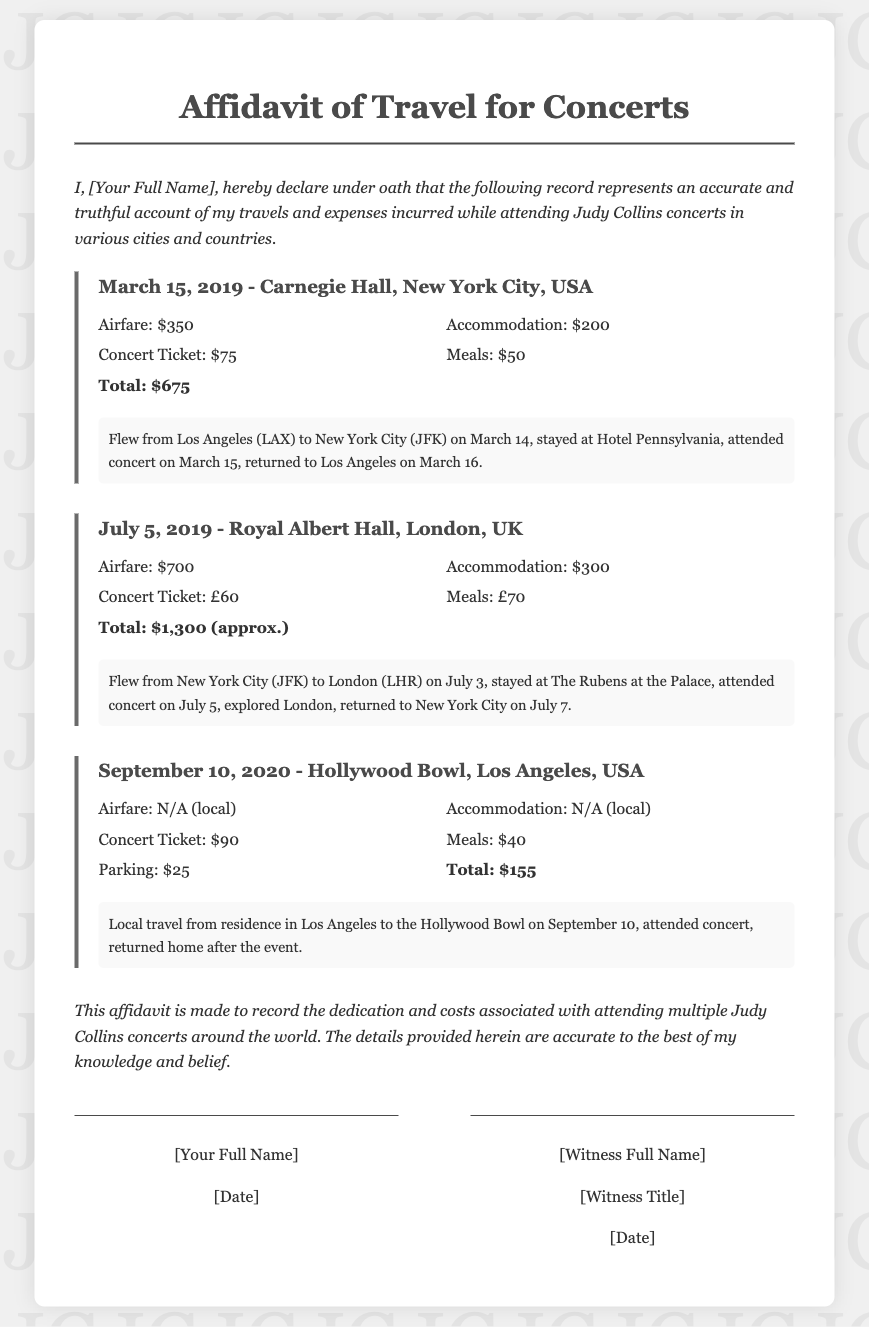What is the date of the concert at Carnegie Hall? The concert at Carnegie Hall took place on March 15, 2019.
Answer: March 15, 2019 What was the total expense for the concert in London? The total expense for the concert in London is calculated from airfare, accommodation, concert ticket, and meals, totaling approximately $1,300.
Answer: $1,300 (approx.) What city hosted Judy Collins on September 10, 2020? The concert on September 10, 2020, was held at the Hollywood Bowl in Los Angeles.
Answer: Los Angeles How much was spent on meals during the concert at Carnegie Hall? The amount spent on meals during the concert at Carnegie Hall was $50.
Answer: $50 What is the name of the hotel where the attendee stayed in London? The attendee stayed at The Rubens at the Palace during the London concert.
Answer: The Rubens at the Palace How is the affidavit intended to represent the author's travels? The affidavit serves to provide an accurate and truthful account of the author's travels and expenses for attending concerts.
Answer: Accurate and truthful account What kind of travel was undertaken to the concert in Los Angeles? The travel to the concert in Los Angeles was local travel.
Answer: Local What is a primary purpose of this affidavit? The primary purpose of the affidavit is to record the dedication and costs associated with attending Judy Collins concerts.
Answer: Record dedication and costs What was the concert ticket price for the Hollywood Bowl concert? The concert ticket price for the Hollywood Bowl concert was $90.
Answer: $90 